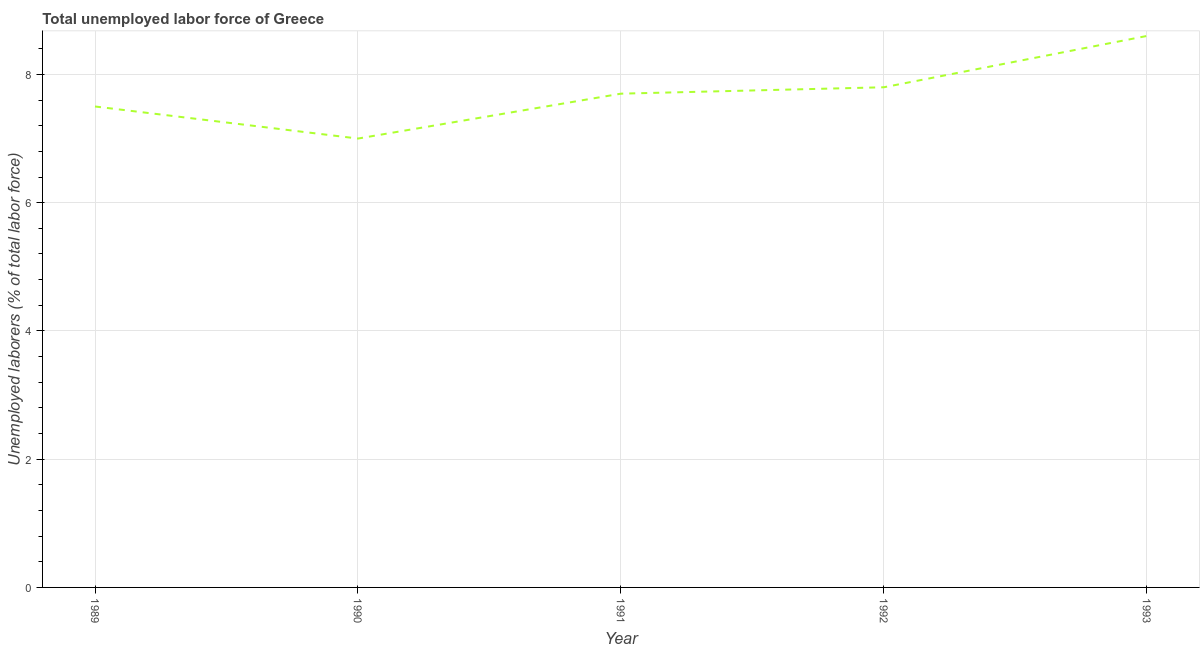What is the total unemployed labour force in 1989?
Give a very brief answer. 7.5. Across all years, what is the maximum total unemployed labour force?
Ensure brevity in your answer.  8.6. Across all years, what is the minimum total unemployed labour force?
Provide a succinct answer. 7. What is the sum of the total unemployed labour force?
Keep it short and to the point. 38.6. What is the difference between the total unemployed labour force in 1991 and 1993?
Provide a short and direct response. -0.9. What is the average total unemployed labour force per year?
Your answer should be very brief. 7.72. What is the median total unemployed labour force?
Your response must be concise. 7.7. Do a majority of the years between 1993 and 1989 (inclusive) have total unemployed labour force greater than 2 %?
Offer a very short reply. Yes. What is the ratio of the total unemployed labour force in 1989 to that in 1991?
Offer a terse response. 0.97. Is the total unemployed labour force in 1990 less than that in 1992?
Provide a short and direct response. Yes. What is the difference between the highest and the second highest total unemployed labour force?
Make the answer very short. 0.8. What is the difference between the highest and the lowest total unemployed labour force?
Ensure brevity in your answer.  1.6. Does the total unemployed labour force monotonically increase over the years?
Your answer should be compact. No. How many years are there in the graph?
Your answer should be compact. 5. What is the difference between two consecutive major ticks on the Y-axis?
Offer a terse response. 2. What is the title of the graph?
Your response must be concise. Total unemployed labor force of Greece. What is the label or title of the X-axis?
Offer a very short reply. Year. What is the label or title of the Y-axis?
Provide a short and direct response. Unemployed laborers (% of total labor force). What is the Unemployed laborers (% of total labor force) in 1991?
Ensure brevity in your answer.  7.7. What is the Unemployed laborers (% of total labor force) in 1992?
Your answer should be compact. 7.8. What is the Unemployed laborers (% of total labor force) of 1993?
Keep it short and to the point. 8.6. What is the difference between the Unemployed laborers (% of total labor force) in 1989 and 1990?
Give a very brief answer. 0.5. What is the difference between the Unemployed laborers (% of total labor force) in 1989 and 1991?
Keep it short and to the point. -0.2. What is the difference between the Unemployed laborers (% of total labor force) in 1989 and 1992?
Give a very brief answer. -0.3. What is the difference between the Unemployed laborers (% of total labor force) in 1989 and 1993?
Your answer should be very brief. -1.1. What is the difference between the Unemployed laborers (% of total labor force) in 1990 and 1993?
Provide a succinct answer. -1.6. What is the difference between the Unemployed laborers (% of total labor force) in 1992 and 1993?
Offer a very short reply. -0.8. What is the ratio of the Unemployed laborers (% of total labor force) in 1989 to that in 1990?
Offer a terse response. 1.07. What is the ratio of the Unemployed laborers (% of total labor force) in 1989 to that in 1992?
Provide a succinct answer. 0.96. What is the ratio of the Unemployed laborers (% of total labor force) in 1989 to that in 1993?
Offer a terse response. 0.87. What is the ratio of the Unemployed laborers (% of total labor force) in 1990 to that in 1991?
Provide a succinct answer. 0.91. What is the ratio of the Unemployed laborers (% of total labor force) in 1990 to that in 1992?
Your response must be concise. 0.9. What is the ratio of the Unemployed laborers (% of total labor force) in 1990 to that in 1993?
Offer a very short reply. 0.81. What is the ratio of the Unemployed laborers (% of total labor force) in 1991 to that in 1993?
Your answer should be compact. 0.9. What is the ratio of the Unemployed laborers (% of total labor force) in 1992 to that in 1993?
Provide a short and direct response. 0.91. 